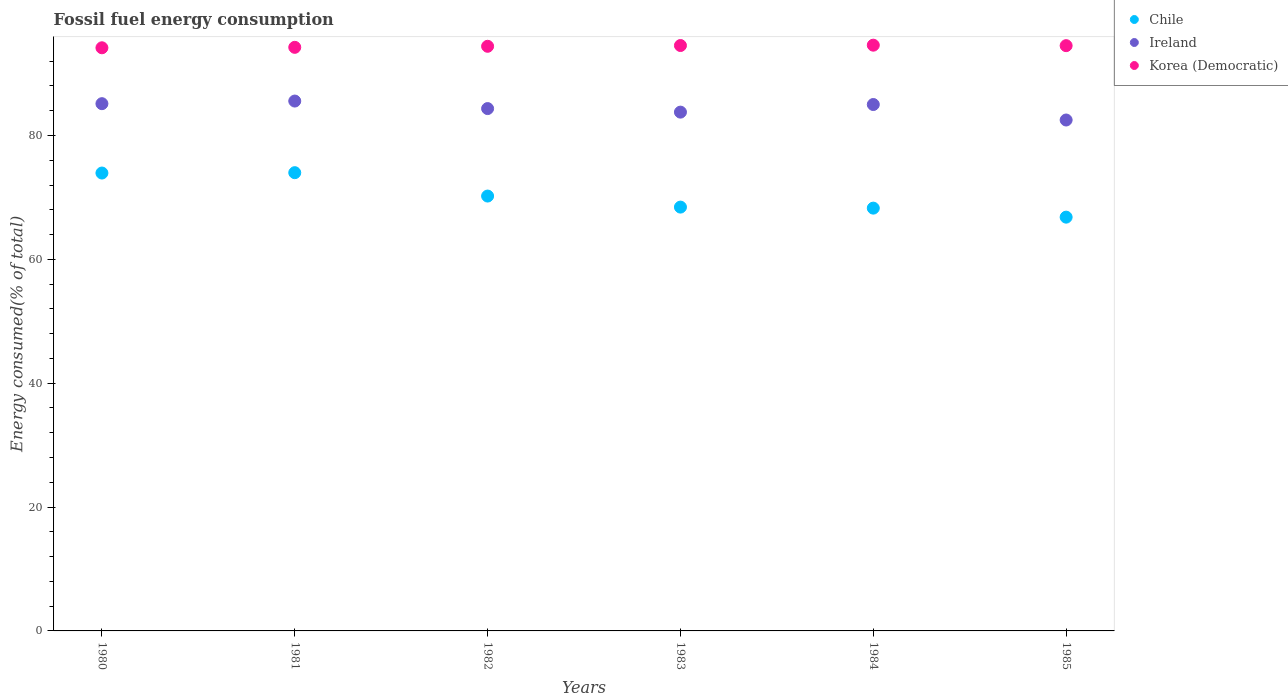Is the number of dotlines equal to the number of legend labels?
Keep it short and to the point. Yes. What is the percentage of energy consumed in Korea (Democratic) in 1983?
Offer a very short reply. 94.53. Across all years, what is the maximum percentage of energy consumed in Chile?
Your answer should be very brief. 73.99. Across all years, what is the minimum percentage of energy consumed in Korea (Democratic)?
Ensure brevity in your answer.  94.16. In which year was the percentage of energy consumed in Chile maximum?
Make the answer very short. 1981. What is the total percentage of energy consumed in Korea (Democratic) in the graph?
Offer a terse response. 566.43. What is the difference between the percentage of energy consumed in Ireland in 1983 and that in 1985?
Offer a terse response. 1.27. What is the difference between the percentage of energy consumed in Ireland in 1980 and the percentage of energy consumed in Korea (Democratic) in 1982?
Your answer should be very brief. -9.27. What is the average percentage of energy consumed in Ireland per year?
Your answer should be very brief. 84.39. In the year 1983, what is the difference between the percentage of energy consumed in Chile and percentage of energy consumed in Korea (Democratic)?
Your response must be concise. -26.09. What is the ratio of the percentage of energy consumed in Korea (Democratic) in 1983 to that in 1984?
Make the answer very short. 1. Is the percentage of energy consumed in Korea (Democratic) in 1983 less than that in 1985?
Offer a very short reply. No. Is the difference between the percentage of energy consumed in Chile in 1982 and 1983 greater than the difference between the percentage of energy consumed in Korea (Democratic) in 1982 and 1983?
Offer a terse response. Yes. What is the difference between the highest and the second highest percentage of energy consumed in Ireland?
Provide a short and direct response. 0.42. What is the difference between the highest and the lowest percentage of energy consumed in Korea (Democratic)?
Offer a very short reply. 0.42. In how many years, is the percentage of energy consumed in Ireland greater than the average percentage of energy consumed in Ireland taken over all years?
Give a very brief answer. 3. Is the sum of the percentage of energy consumed in Chile in 1983 and 1984 greater than the maximum percentage of energy consumed in Ireland across all years?
Offer a terse response. Yes. How many years are there in the graph?
Ensure brevity in your answer.  6. Does the graph contain any zero values?
Ensure brevity in your answer.  No. Does the graph contain grids?
Offer a terse response. No. How many legend labels are there?
Give a very brief answer. 3. What is the title of the graph?
Your answer should be very brief. Fossil fuel energy consumption. What is the label or title of the Y-axis?
Your answer should be compact. Energy consumed(% of total). What is the Energy consumed(% of total) in Chile in 1980?
Offer a very short reply. 73.94. What is the Energy consumed(% of total) in Ireland in 1980?
Provide a short and direct response. 85.14. What is the Energy consumed(% of total) of Korea (Democratic) in 1980?
Provide a succinct answer. 94.16. What is the Energy consumed(% of total) of Chile in 1981?
Your response must be concise. 73.99. What is the Energy consumed(% of total) in Ireland in 1981?
Make the answer very short. 85.56. What is the Energy consumed(% of total) of Korea (Democratic) in 1981?
Your answer should be compact. 94.24. What is the Energy consumed(% of total) of Chile in 1982?
Make the answer very short. 70.22. What is the Energy consumed(% of total) of Ireland in 1982?
Your answer should be very brief. 84.35. What is the Energy consumed(% of total) in Korea (Democratic) in 1982?
Provide a succinct answer. 94.41. What is the Energy consumed(% of total) of Chile in 1983?
Provide a short and direct response. 68.44. What is the Energy consumed(% of total) in Ireland in 1983?
Offer a terse response. 83.77. What is the Energy consumed(% of total) in Korea (Democratic) in 1983?
Keep it short and to the point. 94.53. What is the Energy consumed(% of total) in Chile in 1984?
Your response must be concise. 68.27. What is the Energy consumed(% of total) of Ireland in 1984?
Give a very brief answer. 85. What is the Energy consumed(% of total) in Korea (Democratic) in 1984?
Keep it short and to the point. 94.58. What is the Energy consumed(% of total) of Chile in 1985?
Your answer should be very brief. 66.81. What is the Energy consumed(% of total) of Ireland in 1985?
Give a very brief answer. 82.5. What is the Energy consumed(% of total) in Korea (Democratic) in 1985?
Provide a short and direct response. 94.51. Across all years, what is the maximum Energy consumed(% of total) in Chile?
Ensure brevity in your answer.  73.99. Across all years, what is the maximum Energy consumed(% of total) in Ireland?
Ensure brevity in your answer.  85.56. Across all years, what is the maximum Energy consumed(% of total) in Korea (Democratic)?
Your answer should be very brief. 94.58. Across all years, what is the minimum Energy consumed(% of total) of Chile?
Keep it short and to the point. 66.81. Across all years, what is the minimum Energy consumed(% of total) of Ireland?
Your answer should be compact. 82.5. Across all years, what is the minimum Energy consumed(% of total) in Korea (Democratic)?
Provide a short and direct response. 94.16. What is the total Energy consumed(% of total) of Chile in the graph?
Your answer should be very brief. 421.67. What is the total Energy consumed(% of total) in Ireland in the graph?
Your answer should be compact. 506.32. What is the total Energy consumed(% of total) of Korea (Democratic) in the graph?
Your answer should be compact. 566.43. What is the difference between the Energy consumed(% of total) in Chile in 1980 and that in 1981?
Offer a very short reply. -0.06. What is the difference between the Energy consumed(% of total) in Ireland in 1980 and that in 1981?
Ensure brevity in your answer.  -0.42. What is the difference between the Energy consumed(% of total) of Korea (Democratic) in 1980 and that in 1981?
Offer a terse response. -0.07. What is the difference between the Energy consumed(% of total) in Chile in 1980 and that in 1982?
Make the answer very short. 3.72. What is the difference between the Energy consumed(% of total) in Ireland in 1980 and that in 1982?
Your response must be concise. 0.79. What is the difference between the Energy consumed(% of total) in Korea (Democratic) in 1980 and that in 1982?
Offer a very short reply. -0.24. What is the difference between the Energy consumed(% of total) of Chile in 1980 and that in 1983?
Your answer should be compact. 5.5. What is the difference between the Energy consumed(% of total) of Ireland in 1980 and that in 1983?
Ensure brevity in your answer.  1.37. What is the difference between the Energy consumed(% of total) of Korea (Democratic) in 1980 and that in 1983?
Your answer should be very brief. -0.37. What is the difference between the Energy consumed(% of total) of Chile in 1980 and that in 1984?
Your response must be concise. 5.67. What is the difference between the Energy consumed(% of total) in Ireland in 1980 and that in 1984?
Ensure brevity in your answer.  0.14. What is the difference between the Energy consumed(% of total) of Korea (Democratic) in 1980 and that in 1984?
Give a very brief answer. -0.42. What is the difference between the Energy consumed(% of total) in Chile in 1980 and that in 1985?
Offer a terse response. 7.12. What is the difference between the Energy consumed(% of total) of Ireland in 1980 and that in 1985?
Provide a succinct answer. 2.64. What is the difference between the Energy consumed(% of total) in Korea (Democratic) in 1980 and that in 1985?
Your response must be concise. -0.34. What is the difference between the Energy consumed(% of total) of Chile in 1981 and that in 1982?
Ensure brevity in your answer.  3.77. What is the difference between the Energy consumed(% of total) in Ireland in 1981 and that in 1982?
Provide a succinct answer. 1.22. What is the difference between the Energy consumed(% of total) in Korea (Democratic) in 1981 and that in 1982?
Provide a succinct answer. -0.17. What is the difference between the Energy consumed(% of total) of Chile in 1981 and that in 1983?
Provide a succinct answer. 5.56. What is the difference between the Energy consumed(% of total) of Ireland in 1981 and that in 1983?
Your answer should be very brief. 1.79. What is the difference between the Energy consumed(% of total) of Korea (Democratic) in 1981 and that in 1983?
Keep it short and to the point. -0.29. What is the difference between the Energy consumed(% of total) of Chile in 1981 and that in 1984?
Your answer should be compact. 5.72. What is the difference between the Energy consumed(% of total) of Ireland in 1981 and that in 1984?
Offer a very short reply. 0.56. What is the difference between the Energy consumed(% of total) in Korea (Democratic) in 1981 and that in 1984?
Keep it short and to the point. -0.35. What is the difference between the Energy consumed(% of total) of Chile in 1981 and that in 1985?
Offer a terse response. 7.18. What is the difference between the Energy consumed(% of total) in Ireland in 1981 and that in 1985?
Offer a terse response. 3.06. What is the difference between the Energy consumed(% of total) in Korea (Democratic) in 1981 and that in 1985?
Offer a terse response. -0.27. What is the difference between the Energy consumed(% of total) in Chile in 1982 and that in 1983?
Keep it short and to the point. 1.78. What is the difference between the Energy consumed(% of total) in Ireland in 1982 and that in 1983?
Keep it short and to the point. 0.57. What is the difference between the Energy consumed(% of total) in Korea (Democratic) in 1982 and that in 1983?
Give a very brief answer. -0.12. What is the difference between the Energy consumed(% of total) of Chile in 1982 and that in 1984?
Make the answer very short. 1.95. What is the difference between the Energy consumed(% of total) of Ireland in 1982 and that in 1984?
Provide a succinct answer. -0.66. What is the difference between the Energy consumed(% of total) of Korea (Democratic) in 1982 and that in 1984?
Offer a terse response. -0.18. What is the difference between the Energy consumed(% of total) of Chile in 1982 and that in 1985?
Your answer should be very brief. 3.41. What is the difference between the Energy consumed(% of total) in Ireland in 1982 and that in 1985?
Offer a terse response. 1.84. What is the difference between the Energy consumed(% of total) in Korea (Democratic) in 1982 and that in 1985?
Your answer should be compact. -0.1. What is the difference between the Energy consumed(% of total) in Ireland in 1983 and that in 1984?
Your response must be concise. -1.23. What is the difference between the Energy consumed(% of total) in Korea (Democratic) in 1983 and that in 1984?
Ensure brevity in your answer.  -0.06. What is the difference between the Energy consumed(% of total) in Chile in 1983 and that in 1985?
Offer a very short reply. 1.62. What is the difference between the Energy consumed(% of total) of Ireland in 1983 and that in 1985?
Your answer should be compact. 1.27. What is the difference between the Energy consumed(% of total) of Korea (Democratic) in 1983 and that in 1985?
Offer a terse response. 0.02. What is the difference between the Energy consumed(% of total) in Chile in 1984 and that in 1985?
Provide a short and direct response. 1.46. What is the difference between the Energy consumed(% of total) of Ireland in 1984 and that in 1985?
Your answer should be compact. 2.5. What is the difference between the Energy consumed(% of total) of Korea (Democratic) in 1984 and that in 1985?
Give a very brief answer. 0.08. What is the difference between the Energy consumed(% of total) of Chile in 1980 and the Energy consumed(% of total) of Ireland in 1981?
Your response must be concise. -11.62. What is the difference between the Energy consumed(% of total) of Chile in 1980 and the Energy consumed(% of total) of Korea (Democratic) in 1981?
Offer a terse response. -20.3. What is the difference between the Energy consumed(% of total) in Ireland in 1980 and the Energy consumed(% of total) in Korea (Democratic) in 1981?
Ensure brevity in your answer.  -9.1. What is the difference between the Energy consumed(% of total) of Chile in 1980 and the Energy consumed(% of total) of Ireland in 1982?
Your answer should be compact. -10.41. What is the difference between the Energy consumed(% of total) in Chile in 1980 and the Energy consumed(% of total) in Korea (Democratic) in 1982?
Give a very brief answer. -20.47. What is the difference between the Energy consumed(% of total) of Ireland in 1980 and the Energy consumed(% of total) of Korea (Democratic) in 1982?
Provide a succinct answer. -9.27. What is the difference between the Energy consumed(% of total) of Chile in 1980 and the Energy consumed(% of total) of Ireland in 1983?
Provide a short and direct response. -9.83. What is the difference between the Energy consumed(% of total) of Chile in 1980 and the Energy consumed(% of total) of Korea (Democratic) in 1983?
Provide a short and direct response. -20.59. What is the difference between the Energy consumed(% of total) in Ireland in 1980 and the Energy consumed(% of total) in Korea (Democratic) in 1983?
Make the answer very short. -9.39. What is the difference between the Energy consumed(% of total) of Chile in 1980 and the Energy consumed(% of total) of Ireland in 1984?
Provide a short and direct response. -11.06. What is the difference between the Energy consumed(% of total) in Chile in 1980 and the Energy consumed(% of total) in Korea (Democratic) in 1984?
Ensure brevity in your answer.  -20.65. What is the difference between the Energy consumed(% of total) in Ireland in 1980 and the Energy consumed(% of total) in Korea (Democratic) in 1984?
Your answer should be very brief. -9.45. What is the difference between the Energy consumed(% of total) in Chile in 1980 and the Energy consumed(% of total) in Ireland in 1985?
Ensure brevity in your answer.  -8.56. What is the difference between the Energy consumed(% of total) in Chile in 1980 and the Energy consumed(% of total) in Korea (Democratic) in 1985?
Offer a very short reply. -20.57. What is the difference between the Energy consumed(% of total) in Ireland in 1980 and the Energy consumed(% of total) in Korea (Democratic) in 1985?
Your response must be concise. -9.37. What is the difference between the Energy consumed(% of total) of Chile in 1981 and the Energy consumed(% of total) of Ireland in 1982?
Offer a terse response. -10.35. What is the difference between the Energy consumed(% of total) in Chile in 1981 and the Energy consumed(% of total) in Korea (Democratic) in 1982?
Your answer should be compact. -20.41. What is the difference between the Energy consumed(% of total) in Ireland in 1981 and the Energy consumed(% of total) in Korea (Democratic) in 1982?
Offer a very short reply. -8.84. What is the difference between the Energy consumed(% of total) of Chile in 1981 and the Energy consumed(% of total) of Ireland in 1983?
Provide a short and direct response. -9.78. What is the difference between the Energy consumed(% of total) in Chile in 1981 and the Energy consumed(% of total) in Korea (Democratic) in 1983?
Ensure brevity in your answer.  -20.53. What is the difference between the Energy consumed(% of total) in Ireland in 1981 and the Energy consumed(% of total) in Korea (Democratic) in 1983?
Keep it short and to the point. -8.97. What is the difference between the Energy consumed(% of total) of Chile in 1981 and the Energy consumed(% of total) of Ireland in 1984?
Provide a short and direct response. -11.01. What is the difference between the Energy consumed(% of total) of Chile in 1981 and the Energy consumed(% of total) of Korea (Democratic) in 1984?
Give a very brief answer. -20.59. What is the difference between the Energy consumed(% of total) in Ireland in 1981 and the Energy consumed(% of total) in Korea (Democratic) in 1984?
Give a very brief answer. -9.02. What is the difference between the Energy consumed(% of total) of Chile in 1981 and the Energy consumed(% of total) of Ireland in 1985?
Your answer should be compact. -8.51. What is the difference between the Energy consumed(% of total) in Chile in 1981 and the Energy consumed(% of total) in Korea (Democratic) in 1985?
Your response must be concise. -20.51. What is the difference between the Energy consumed(% of total) of Ireland in 1981 and the Energy consumed(% of total) of Korea (Democratic) in 1985?
Offer a terse response. -8.94. What is the difference between the Energy consumed(% of total) in Chile in 1982 and the Energy consumed(% of total) in Ireland in 1983?
Provide a short and direct response. -13.55. What is the difference between the Energy consumed(% of total) in Chile in 1982 and the Energy consumed(% of total) in Korea (Democratic) in 1983?
Your answer should be compact. -24.31. What is the difference between the Energy consumed(% of total) of Ireland in 1982 and the Energy consumed(% of total) of Korea (Democratic) in 1983?
Provide a short and direct response. -10.18. What is the difference between the Energy consumed(% of total) in Chile in 1982 and the Energy consumed(% of total) in Ireland in 1984?
Offer a terse response. -14.78. What is the difference between the Energy consumed(% of total) of Chile in 1982 and the Energy consumed(% of total) of Korea (Democratic) in 1984?
Offer a terse response. -24.36. What is the difference between the Energy consumed(% of total) in Ireland in 1982 and the Energy consumed(% of total) in Korea (Democratic) in 1984?
Offer a terse response. -10.24. What is the difference between the Energy consumed(% of total) of Chile in 1982 and the Energy consumed(% of total) of Ireland in 1985?
Offer a very short reply. -12.28. What is the difference between the Energy consumed(% of total) in Chile in 1982 and the Energy consumed(% of total) in Korea (Democratic) in 1985?
Your response must be concise. -24.29. What is the difference between the Energy consumed(% of total) of Ireland in 1982 and the Energy consumed(% of total) of Korea (Democratic) in 1985?
Make the answer very short. -10.16. What is the difference between the Energy consumed(% of total) of Chile in 1983 and the Energy consumed(% of total) of Ireland in 1984?
Offer a very short reply. -16.56. What is the difference between the Energy consumed(% of total) of Chile in 1983 and the Energy consumed(% of total) of Korea (Democratic) in 1984?
Offer a very short reply. -26.15. What is the difference between the Energy consumed(% of total) in Ireland in 1983 and the Energy consumed(% of total) in Korea (Democratic) in 1984?
Keep it short and to the point. -10.81. What is the difference between the Energy consumed(% of total) in Chile in 1983 and the Energy consumed(% of total) in Ireland in 1985?
Your response must be concise. -14.06. What is the difference between the Energy consumed(% of total) of Chile in 1983 and the Energy consumed(% of total) of Korea (Democratic) in 1985?
Offer a terse response. -26.07. What is the difference between the Energy consumed(% of total) in Ireland in 1983 and the Energy consumed(% of total) in Korea (Democratic) in 1985?
Your answer should be compact. -10.73. What is the difference between the Energy consumed(% of total) in Chile in 1984 and the Energy consumed(% of total) in Ireland in 1985?
Offer a terse response. -14.23. What is the difference between the Energy consumed(% of total) of Chile in 1984 and the Energy consumed(% of total) of Korea (Democratic) in 1985?
Give a very brief answer. -26.24. What is the difference between the Energy consumed(% of total) in Ireland in 1984 and the Energy consumed(% of total) in Korea (Democratic) in 1985?
Provide a short and direct response. -9.5. What is the average Energy consumed(% of total) in Chile per year?
Your answer should be very brief. 70.28. What is the average Energy consumed(% of total) of Ireland per year?
Give a very brief answer. 84.39. What is the average Energy consumed(% of total) in Korea (Democratic) per year?
Your response must be concise. 94.4. In the year 1980, what is the difference between the Energy consumed(% of total) in Chile and Energy consumed(% of total) in Ireland?
Keep it short and to the point. -11.2. In the year 1980, what is the difference between the Energy consumed(% of total) of Chile and Energy consumed(% of total) of Korea (Democratic)?
Give a very brief answer. -20.23. In the year 1980, what is the difference between the Energy consumed(% of total) in Ireland and Energy consumed(% of total) in Korea (Democratic)?
Your response must be concise. -9.02. In the year 1981, what is the difference between the Energy consumed(% of total) of Chile and Energy consumed(% of total) of Ireland?
Provide a short and direct response. -11.57. In the year 1981, what is the difference between the Energy consumed(% of total) in Chile and Energy consumed(% of total) in Korea (Democratic)?
Offer a very short reply. -20.24. In the year 1981, what is the difference between the Energy consumed(% of total) in Ireland and Energy consumed(% of total) in Korea (Democratic)?
Keep it short and to the point. -8.67. In the year 1982, what is the difference between the Energy consumed(% of total) of Chile and Energy consumed(% of total) of Ireland?
Your response must be concise. -14.13. In the year 1982, what is the difference between the Energy consumed(% of total) in Chile and Energy consumed(% of total) in Korea (Democratic)?
Your answer should be very brief. -24.19. In the year 1982, what is the difference between the Energy consumed(% of total) of Ireland and Energy consumed(% of total) of Korea (Democratic)?
Your answer should be compact. -10.06. In the year 1983, what is the difference between the Energy consumed(% of total) in Chile and Energy consumed(% of total) in Ireland?
Your answer should be very brief. -15.34. In the year 1983, what is the difference between the Energy consumed(% of total) in Chile and Energy consumed(% of total) in Korea (Democratic)?
Give a very brief answer. -26.09. In the year 1983, what is the difference between the Energy consumed(% of total) in Ireland and Energy consumed(% of total) in Korea (Democratic)?
Provide a succinct answer. -10.76. In the year 1984, what is the difference between the Energy consumed(% of total) in Chile and Energy consumed(% of total) in Ireland?
Provide a short and direct response. -16.73. In the year 1984, what is the difference between the Energy consumed(% of total) of Chile and Energy consumed(% of total) of Korea (Democratic)?
Your answer should be compact. -26.31. In the year 1984, what is the difference between the Energy consumed(% of total) in Ireland and Energy consumed(% of total) in Korea (Democratic)?
Make the answer very short. -9.58. In the year 1985, what is the difference between the Energy consumed(% of total) of Chile and Energy consumed(% of total) of Ireland?
Provide a short and direct response. -15.69. In the year 1985, what is the difference between the Energy consumed(% of total) in Chile and Energy consumed(% of total) in Korea (Democratic)?
Your response must be concise. -27.69. In the year 1985, what is the difference between the Energy consumed(% of total) in Ireland and Energy consumed(% of total) in Korea (Democratic)?
Offer a terse response. -12.01. What is the ratio of the Energy consumed(% of total) of Chile in 1980 to that in 1981?
Your answer should be compact. 1. What is the ratio of the Energy consumed(% of total) of Ireland in 1980 to that in 1981?
Give a very brief answer. 1. What is the ratio of the Energy consumed(% of total) of Korea (Democratic) in 1980 to that in 1981?
Provide a short and direct response. 1. What is the ratio of the Energy consumed(% of total) in Chile in 1980 to that in 1982?
Keep it short and to the point. 1.05. What is the ratio of the Energy consumed(% of total) in Ireland in 1980 to that in 1982?
Give a very brief answer. 1.01. What is the ratio of the Energy consumed(% of total) of Korea (Democratic) in 1980 to that in 1982?
Your answer should be very brief. 1. What is the ratio of the Energy consumed(% of total) of Chile in 1980 to that in 1983?
Offer a terse response. 1.08. What is the ratio of the Energy consumed(% of total) of Ireland in 1980 to that in 1983?
Provide a short and direct response. 1.02. What is the ratio of the Energy consumed(% of total) of Chile in 1980 to that in 1984?
Give a very brief answer. 1.08. What is the ratio of the Energy consumed(% of total) in Ireland in 1980 to that in 1984?
Make the answer very short. 1. What is the ratio of the Energy consumed(% of total) of Korea (Democratic) in 1980 to that in 1984?
Your response must be concise. 1. What is the ratio of the Energy consumed(% of total) of Chile in 1980 to that in 1985?
Make the answer very short. 1.11. What is the ratio of the Energy consumed(% of total) in Ireland in 1980 to that in 1985?
Offer a terse response. 1.03. What is the ratio of the Energy consumed(% of total) of Chile in 1981 to that in 1982?
Keep it short and to the point. 1.05. What is the ratio of the Energy consumed(% of total) of Ireland in 1981 to that in 1982?
Your answer should be very brief. 1.01. What is the ratio of the Energy consumed(% of total) of Chile in 1981 to that in 1983?
Give a very brief answer. 1.08. What is the ratio of the Energy consumed(% of total) of Ireland in 1981 to that in 1983?
Offer a very short reply. 1.02. What is the ratio of the Energy consumed(% of total) in Chile in 1981 to that in 1984?
Your response must be concise. 1.08. What is the ratio of the Energy consumed(% of total) of Ireland in 1981 to that in 1984?
Make the answer very short. 1.01. What is the ratio of the Energy consumed(% of total) of Korea (Democratic) in 1981 to that in 1984?
Your response must be concise. 1. What is the ratio of the Energy consumed(% of total) of Chile in 1981 to that in 1985?
Your response must be concise. 1.11. What is the ratio of the Energy consumed(% of total) in Ireland in 1981 to that in 1985?
Provide a short and direct response. 1.04. What is the ratio of the Energy consumed(% of total) in Chile in 1982 to that in 1983?
Make the answer very short. 1.03. What is the ratio of the Energy consumed(% of total) in Ireland in 1982 to that in 1983?
Keep it short and to the point. 1.01. What is the ratio of the Energy consumed(% of total) of Chile in 1982 to that in 1984?
Your answer should be compact. 1.03. What is the ratio of the Energy consumed(% of total) of Korea (Democratic) in 1982 to that in 1984?
Keep it short and to the point. 1. What is the ratio of the Energy consumed(% of total) of Chile in 1982 to that in 1985?
Your response must be concise. 1.05. What is the ratio of the Energy consumed(% of total) in Ireland in 1982 to that in 1985?
Provide a succinct answer. 1.02. What is the ratio of the Energy consumed(% of total) of Ireland in 1983 to that in 1984?
Offer a very short reply. 0.99. What is the ratio of the Energy consumed(% of total) in Korea (Democratic) in 1983 to that in 1984?
Provide a succinct answer. 1. What is the ratio of the Energy consumed(% of total) of Chile in 1983 to that in 1985?
Your answer should be very brief. 1.02. What is the ratio of the Energy consumed(% of total) in Ireland in 1983 to that in 1985?
Provide a succinct answer. 1.02. What is the ratio of the Energy consumed(% of total) in Chile in 1984 to that in 1985?
Provide a succinct answer. 1.02. What is the ratio of the Energy consumed(% of total) in Ireland in 1984 to that in 1985?
Keep it short and to the point. 1.03. What is the difference between the highest and the second highest Energy consumed(% of total) of Chile?
Your answer should be very brief. 0.06. What is the difference between the highest and the second highest Energy consumed(% of total) in Ireland?
Your answer should be compact. 0.42. What is the difference between the highest and the second highest Energy consumed(% of total) of Korea (Democratic)?
Offer a terse response. 0.06. What is the difference between the highest and the lowest Energy consumed(% of total) in Chile?
Your answer should be very brief. 7.18. What is the difference between the highest and the lowest Energy consumed(% of total) of Ireland?
Provide a succinct answer. 3.06. What is the difference between the highest and the lowest Energy consumed(% of total) in Korea (Democratic)?
Your answer should be compact. 0.42. 